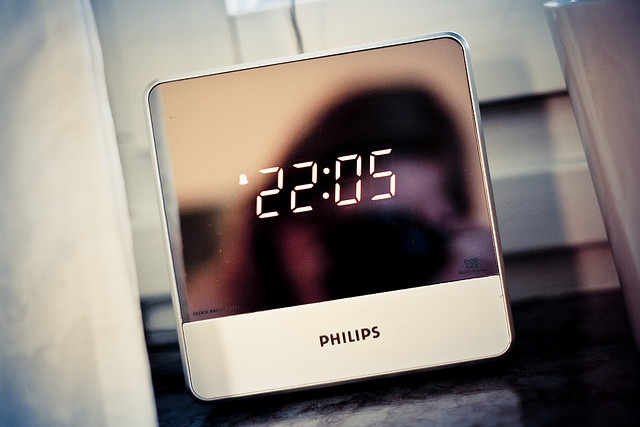Describe the objects in this image and their specific colors. I can see a clock in gray, black, tan, and maroon tones in this image. 